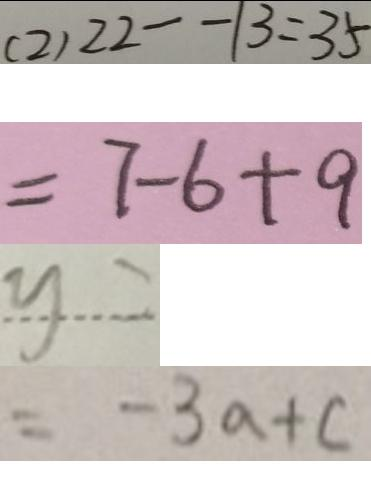<formula> <loc_0><loc_0><loc_500><loc_500>( 2 ) 2 2 - - 1 3 = 3 5 
 = 7 - 6 + 9 
 y = 
 = - 3 a + c</formula> 